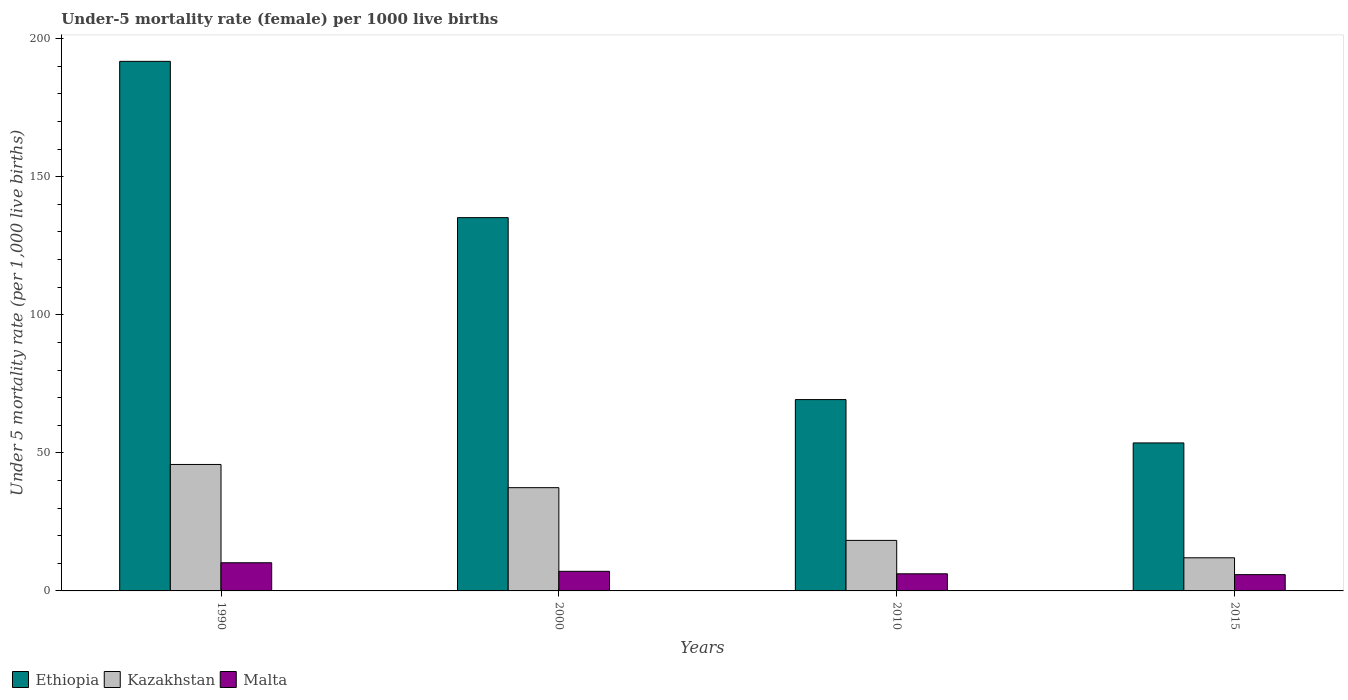How many groups of bars are there?
Provide a short and direct response. 4. Are the number of bars per tick equal to the number of legend labels?
Give a very brief answer. Yes. How many bars are there on the 2nd tick from the left?
Your answer should be compact. 3. How many bars are there on the 4th tick from the right?
Ensure brevity in your answer.  3. Across all years, what is the minimum under-five mortality rate in Ethiopia?
Your answer should be compact. 53.6. In which year was the under-five mortality rate in Kazakhstan minimum?
Provide a succinct answer. 2015. What is the total under-five mortality rate in Malta in the graph?
Offer a terse response. 29.4. What is the difference between the under-five mortality rate in Malta in 1990 and that in 2000?
Make the answer very short. 3.1. What is the difference between the under-five mortality rate in Ethiopia in 2000 and the under-five mortality rate in Kazakhstan in 2015?
Give a very brief answer. 123.2. What is the average under-five mortality rate in Kazakhstan per year?
Provide a succinct answer. 28.37. In the year 2015, what is the difference between the under-five mortality rate in Malta and under-five mortality rate in Ethiopia?
Ensure brevity in your answer.  -47.7. In how many years, is the under-five mortality rate in Kazakhstan greater than 160?
Offer a terse response. 0. What is the ratio of the under-five mortality rate in Malta in 1990 to that in 2015?
Provide a short and direct response. 1.73. Is the under-five mortality rate in Kazakhstan in 2000 less than that in 2010?
Offer a terse response. No. Is the difference between the under-five mortality rate in Malta in 1990 and 2010 greater than the difference between the under-five mortality rate in Ethiopia in 1990 and 2010?
Provide a short and direct response. No. What is the difference between the highest and the second highest under-five mortality rate in Kazakhstan?
Provide a succinct answer. 8.4. What is the difference between the highest and the lowest under-five mortality rate in Malta?
Ensure brevity in your answer.  4.3. In how many years, is the under-five mortality rate in Ethiopia greater than the average under-five mortality rate in Ethiopia taken over all years?
Provide a short and direct response. 2. What does the 1st bar from the left in 2010 represents?
Make the answer very short. Ethiopia. What does the 2nd bar from the right in 2000 represents?
Your answer should be very brief. Kazakhstan. How many legend labels are there?
Provide a short and direct response. 3. What is the title of the graph?
Your answer should be compact. Under-5 mortality rate (female) per 1000 live births. What is the label or title of the X-axis?
Offer a very short reply. Years. What is the label or title of the Y-axis?
Provide a short and direct response. Under 5 mortality rate (per 1,0 live births). What is the Under 5 mortality rate (per 1,000 live births) of Ethiopia in 1990?
Make the answer very short. 191.8. What is the Under 5 mortality rate (per 1,000 live births) of Kazakhstan in 1990?
Your answer should be very brief. 45.8. What is the Under 5 mortality rate (per 1,000 live births) in Ethiopia in 2000?
Your response must be concise. 135.2. What is the Under 5 mortality rate (per 1,000 live births) of Kazakhstan in 2000?
Ensure brevity in your answer.  37.4. What is the Under 5 mortality rate (per 1,000 live births) in Malta in 2000?
Your answer should be very brief. 7.1. What is the Under 5 mortality rate (per 1,000 live births) in Ethiopia in 2010?
Provide a short and direct response. 69.3. What is the Under 5 mortality rate (per 1,000 live births) in Kazakhstan in 2010?
Make the answer very short. 18.3. What is the Under 5 mortality rate (per 1,000 live births) of Ethiopia in 2015?
Your answer should be very brief. 53.6. What is the Under 5 mortality rate (per 1,000 live births) of Kazakhstan in 2015?
Your response must be concise. 12. What is the Under 5 mortality rate (per 1,000 live births) of Malta in 2015?
Keep it short and to the point. 5.9. Across all years, what is the maximum Under 5 mortality rate (per 1,000 live births) in Ethiopia?
Ensure brevity in your answer.  191.8. Across all years, what is the maximum Under 5 mortality rate (per 1,000 live births) of Kazakhstan?
Provide a succinct answer. 45.8. Across all years, what is the minimum Under 5 mortality rate (per 1,000 live births) in Ethiopia?
Offer a very short reply. 53.6. What is the total Under 5 mortality rate (per 1,000 live births) in Ethiopia in the graph?
Give a very brief answer. 449.9. What is the total Under 5 mortality rate (per 1,000 live births) in Kazakhstan in the graph?
Offer a very short reply. 113.5. What is the total Under 5 mortality rate (per 1,000 live births) in Malta in the graph?
Your answer should be compact. 29.4. What is the difference between the Under 5 mortality rate (per 1,000 live births) in Ethiopia in 1990 and that in 2000?
Ensure brevity in your answer.  56.6. What is the difference between the Under 5 mortality rate (per 1,000 live births) in Kazakhstan in 1990 and that in 2000?
Keep it short and to the point. 8.4. What is the difference between the Under 5 mortality rate (per 1,000 live births) of Malta in 1990 and that in 2000?
Ensure brevity in your answer.  3.1. What is the difference between the Under 5 mortality rate (per 1,000 live births) of Ethiopia in 1990 and that in 2010?
Keep it short and to the point. 122.5. What is the difference between the Under 5 mortality rate (per 1,000 live births) of Kazakhstan in 1990 and that in 2010?
Your answer should be very brief. 27.5. What is the difference between the Under 5 mortality rate (per 1,000 live births) in Malta in 1990 and that in 2010?
Provide a short and direct response. 4. What is the difference between the Under 5 mortality rate (per 1,000 live births) in Ethiopia in 1990 and that in 2015?
Keep it short and to the point. 138.2. What is the difference between the Under 5 mortality rate (per 1,000 live births) of Kazakhstan in 1990 and that in 2015?
Offer a terse response. 33.8. What is the difference between the Under 5 mortality rate (per 1,000 live births) in Malta in 1990 and that in 2015?
Provide a succinct answer. 4.3. What is the difference between the Under 5 mortality rate (per 1,000 live births) in Ethiopia in 2000 and that in 2010?
Offer a very short reply. 65.9. What is the difference between the Under 5 mortality rate (per 1,000 live births) of Kazakhstan in 2000 and that in 2010?
Make the answer very short. 19.1. What is the difference between the Under 5 mortality rate (per 1,000 live births) of Ethiopia in 2000 and that in 2015?
Make the answer very short. 81.6. What is the difference between the Under 5 mortality rate (per 1,000 live births) in Kazakhstan in 2000 and that in 2015?
Offer a terse response. 25.4. What is the difference between the Under 5 mortality rate (per 1,000 live births) in Kazakhstan in 2010 and that in 2015?
Provide a short and direct response. 6.3. What is the difference between the Under 5 mortality rate (per 1,000 live births) in Ethiopia in 1990 and the Under 5 mortality rate (per 1,000 live births) in Kazakhstan in 2000?
Your response must be concise. 154.4. What is the difference between the Under 5 mortality rate (per 1,000 live births) of Ethiopia in 1990 and the Under 5 mortality rate (per 1,000 live births) of Malta in 2000?
Ensure brevity in your answer.  184.7. What is the difference between the Under 5 mortality rate (per 1,000 live births) of Kazakhstan in 1990 and the Under 5 mortality rate (per 1,000 live births) of Malta in 2000?
Keep it short and to the point. 38.7. What is the difference between the Under 5 mortality rate (per 1,000 live births) in Ethiopia in 1990 and the Under 5 mortality rate (per 1,000 live births) in Kazakhstan in 2010?
Your response must be concise. 173.5. What is the difference between the Under 5 mortality rate (per 1,000 live births) in Ethiopia in 1990 and the Under 5 mortality rate (per 1,000 live births) in Malta in 2010?
Offer a very short reply. 185.6. What is the difference between the Under 5 mortality rate (per 1,000 live births) in Kazakhstan in 1990 and the Under 5 mortality rate (per 1,000 live births) in Malta in 2010?
Provide a succinct answer. 39.6. What is the difference between the Under 5 mortality rate (per 1,000 live births) in Ethiopia in 1990 and the Under 5 mortality rate (per 1,000 live births) in Kazakhstan in 2015?
Give a very brief answer. 179.8. What is the difference between the Under 5 mortality rate (per 1,000 live births) in Ethiopia in 1990 and the Under 5 mortality rate (per 1,000 live births) in Malta in 2015?
Your response must be concise. 185.9. What is the difference between the Under 5 mortality rate (per 1,000 live births) of Kazakhstan in 1990 and the Under 5 mortality rate (per 1,000 live births) of Malta in 2015?
Offer a very short reply. 39.9. What is the difference between the Under 5 mortality rate (per 1,000 live births) in Ethiopia in 2000 and the Under 5 mortality rate (per 1,000 live births) in Kazakhstan in 2010?
Your answer should be very brief. 116.9. What is the difference between the Under 5 mortality rate (per 1,000 live births) of Ethiopia in 2000 and the Under 5 mortality rate (per 1,000 live births) of Malta in 2010?
Provide a short and direct response. 129. What is the difference between the Under 5 mortality rate (per 1,000 live births) in Kazakhstan in 2000 and the Under 5 mortality rate (per 1,000 live births) in Malta in 2010?
Make the answer very short. 31.2. What is the difference between the Under 5 mortality rate (per 1,000 live births) of Ethiopia in 2000 and the Under 5 mortality rate (per 1,000 live births) of Kazakhstan in 2015?
Make the answer very short. 123.2. What is the difference between the Under 5 mortality rate (per 1,000 live births) of Ethiopia in 2000 and the Under 5 mortality rate (per 1,000 live births) of Malta in 2015?
Provide a succinct answer. 129.3. What is the difference between the Under 5 mortality rate (per 1,000 live births) of Kazakhstan in 2000 and the Under 5 mortality rate (per 1,000 live births) of Malta in 2015?
Your answer should be very brief. 31.5. What is the difference between the Under 5 mortality rate (per 1,000 live births) in Ethiopia in 2010 and the Under 5 mortality rate (per 1,000 live births) in Kazakhstan in 2015?
Provide a short and direct response. 57.3. What is the difference between the Under 5 mortality rate (per 1,000 live births) of Ethiopia in 2010 and the Under 5 mortality rate (per 1,000 live births) of Malta in 2015?
Provide a succinct answer. 63.4. What is the average Under 5 mortality rate (per 1,000 live births) in Ethiopia per year?
Offer a very short reply. 112.47. What is the average Under 5 mortality rate (per 1,000 live births) of Kazakhstan per year?
Make the answer very short. 28.38. What is the average Under 5 mortality rate (per 1,000 live births) of Malta per year?
Ensure brevity in your answer.  7.35. In the year 1990, what is the difference between the Under 5 mortality rate (per 1,000 live births) in Ethiopia and Under 5 mortality rate (per 1,000 live births) in Kazakhstan?
Give a very brief answer. 146. In the year 1990, what is the difference between the Under 5 mortality rate (per 1,000 live births) in Ethiopia and Under 5 mortality rate (per 1,000 live births) in Malta?
Offer a terse response. 181.6. In the year 1990, what is the difference between the Under 5 mortality rate (per 1,000 live births) in Kazakhstan and Under 5 mortality rate (per 1,000 live births) in Malta?
Give a very brief answer. 35.6. In the year 2000, what is the difference between the Under 5 mortality rate (per 1,000 live births) in Ethiopia and Under 5 mortality rate (per 1,000 live births) in Kazakhstan?
Offer a very short reply. 97.8. In the year 2000, what is the difference between the Under 5 mortality rate (per 1,000 live births) of Ethiopia and Under 5 mortality rate (per 1,000 live births) of Malta?
Provide a succinct answer. 128.1. In the year 2000, what is the difference between the Under 5 mortality rate (per 1,000 live births) in Kazakhstan and Under 5 mortality rate (per 1,000 live births) in Malta?
Provide a short and direct response. 30.3. In the year 2010, what is the difference between the Under 5 mortality rate (per 1,000 live births) in Ethiopia and Under 5 mortality rate (per 1,000 live births) in Kazakhstan?
Your answer should be compact. 51. In the year 2010, what is the difference between the Under 5 mortality rate (per 1,000 live births) of Ethiopia and Under 5 mortality rate (per 1,000 live births) of Malta?
Your answer should be very brief. 63.1. In the year 2015, what is the difference between the Under 5 mortality rate (per 1,000 live births) in Ethiopia and Under 5 mortality rate (per 1,000 live births) in Kazakhstan?
Offer a very short reply. 41.6. In the year 2015, what is the difference between the Under 5 mortality rate (per 1,000 live births) of Ethiopia and Under 5 mortality rate (per 1,000 live births) of Malta?
Offer a terse response. 47.7. What is the ratio of the Under 5 mortality rate (per 1,000 live births) of Ethiopia in 1990 to that in 2000?
Your answer should be compact. 1.42. What is the ratio of the Under 5 mortality rate (per 1,000 live births) in Kazakhstan in 1990 to that in 2000?
Keep it short and to the point. 1.22. What is the ratio of the Under 5 mortality rate (per 1,000 live births) in Malta in 1990 to that in 2000?
Your answer should be compact. 1.44. What is the ratio of the Under 5 mortality rate (per 1,000 live births) in Ethiopia in 1990 to that in 2010?
Your answer should be very brief. 2.77. What is the ratio of the Under 5 mortality rate (per 1,000 live births) in Kazakhstan in 1990 to that in 2010?
Provide a short and direct response. 2.5. What is the ratio of the Under 5 mortality rate (per 1,000 live births) of Malta in 1990 to that in 2010?
Your response must be concise. 1.65. What is the ratio of the Under 5 mortality rate (per 1,000 live births) of Ethiopia in 1990 to that in 2015?
Give a very brief answer. 3.58. What is the ratio of the Under 5 mortality rate (per 1,000 live births) of Kazakhstan in 1990 to that in 2015?
Keep it short and to the point. 3.82. What is the ratio of the Under 5 mortality rate (per 1,000 live births) of Malta in 1990 to that in 2015?
Keep it short and to the point. 1.73. What is the ratio of the Under 5 mortality rate (per 1,000 live births) in Ethiopia in 2000 to that in 2010?
Give a very brief answer. 1.95. What is the ratio of the Under 5 mortality rate (per 1,000 live births) of Kazakhstan in 2000 to that in 2010?
Offer a terse response. 2.04. What is the ratio of the Under 5 mortality rate (per 1,000 live births) in Malta in 2000 to that in 2010?
Give a very brief answer. 1.15. What is the ratio of the Under 5 mortality rate (per 1,000 live births) in Ethiopia in 2000 to that in 2015?
Provide a short and direct response. 2.52. What is the ratio of the Under 5 mortality rate (per 1,000 live births) in Kazakhstan in 2000 to that in 2015?
Offer a very short reply. 3.12. What is the ratio of the Under 5 mortality rate (per 1,000 live births) in Malta in 2000 to that in 2015?
Your response must be concise. 1.2. What is the ratio of the Under 5 mortality rate (per 1,000 live births) in Ethiopia in 2010 to that in 2015?
Make the answer very short. 1.29. What is the ratio of the Under 5 mortality rate (per 1,000 live births) in Kazakhstan in 2010 to that in 2015?
Your response must be concise. 1.52. What is the ratio of the Under 5 mortality rate (per 1,000 live births) in Malta in 2010 to that in 2015?
Ensure brevity in your answer.  1.05. What is the difference between the highest and the second highest Under 5 mortality rate (per 1,000 live births) of Ethiopia?
Provide a succinct answer. 56.6. What is the difference between the highest and the lowest Under 5 mortality rate (per 1,000 live births) of Ethiopia?
Your answer should be very brief. 138.2. What is the difference between the highest and the lowest Under 5 mortality rate (per 1,000 live births) in Kazakhstan?
Your answer should be very brief. 33.8. 